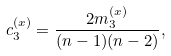<formula> <loc_0><loc_0><loc_500><loc_500>c _ { 3 } ^ { ( x ) } = \frac { 2 m _ { 3 } ^ { ( x ) } } { ( n - 1 ) ( n - 2 ) } ,</formula> 